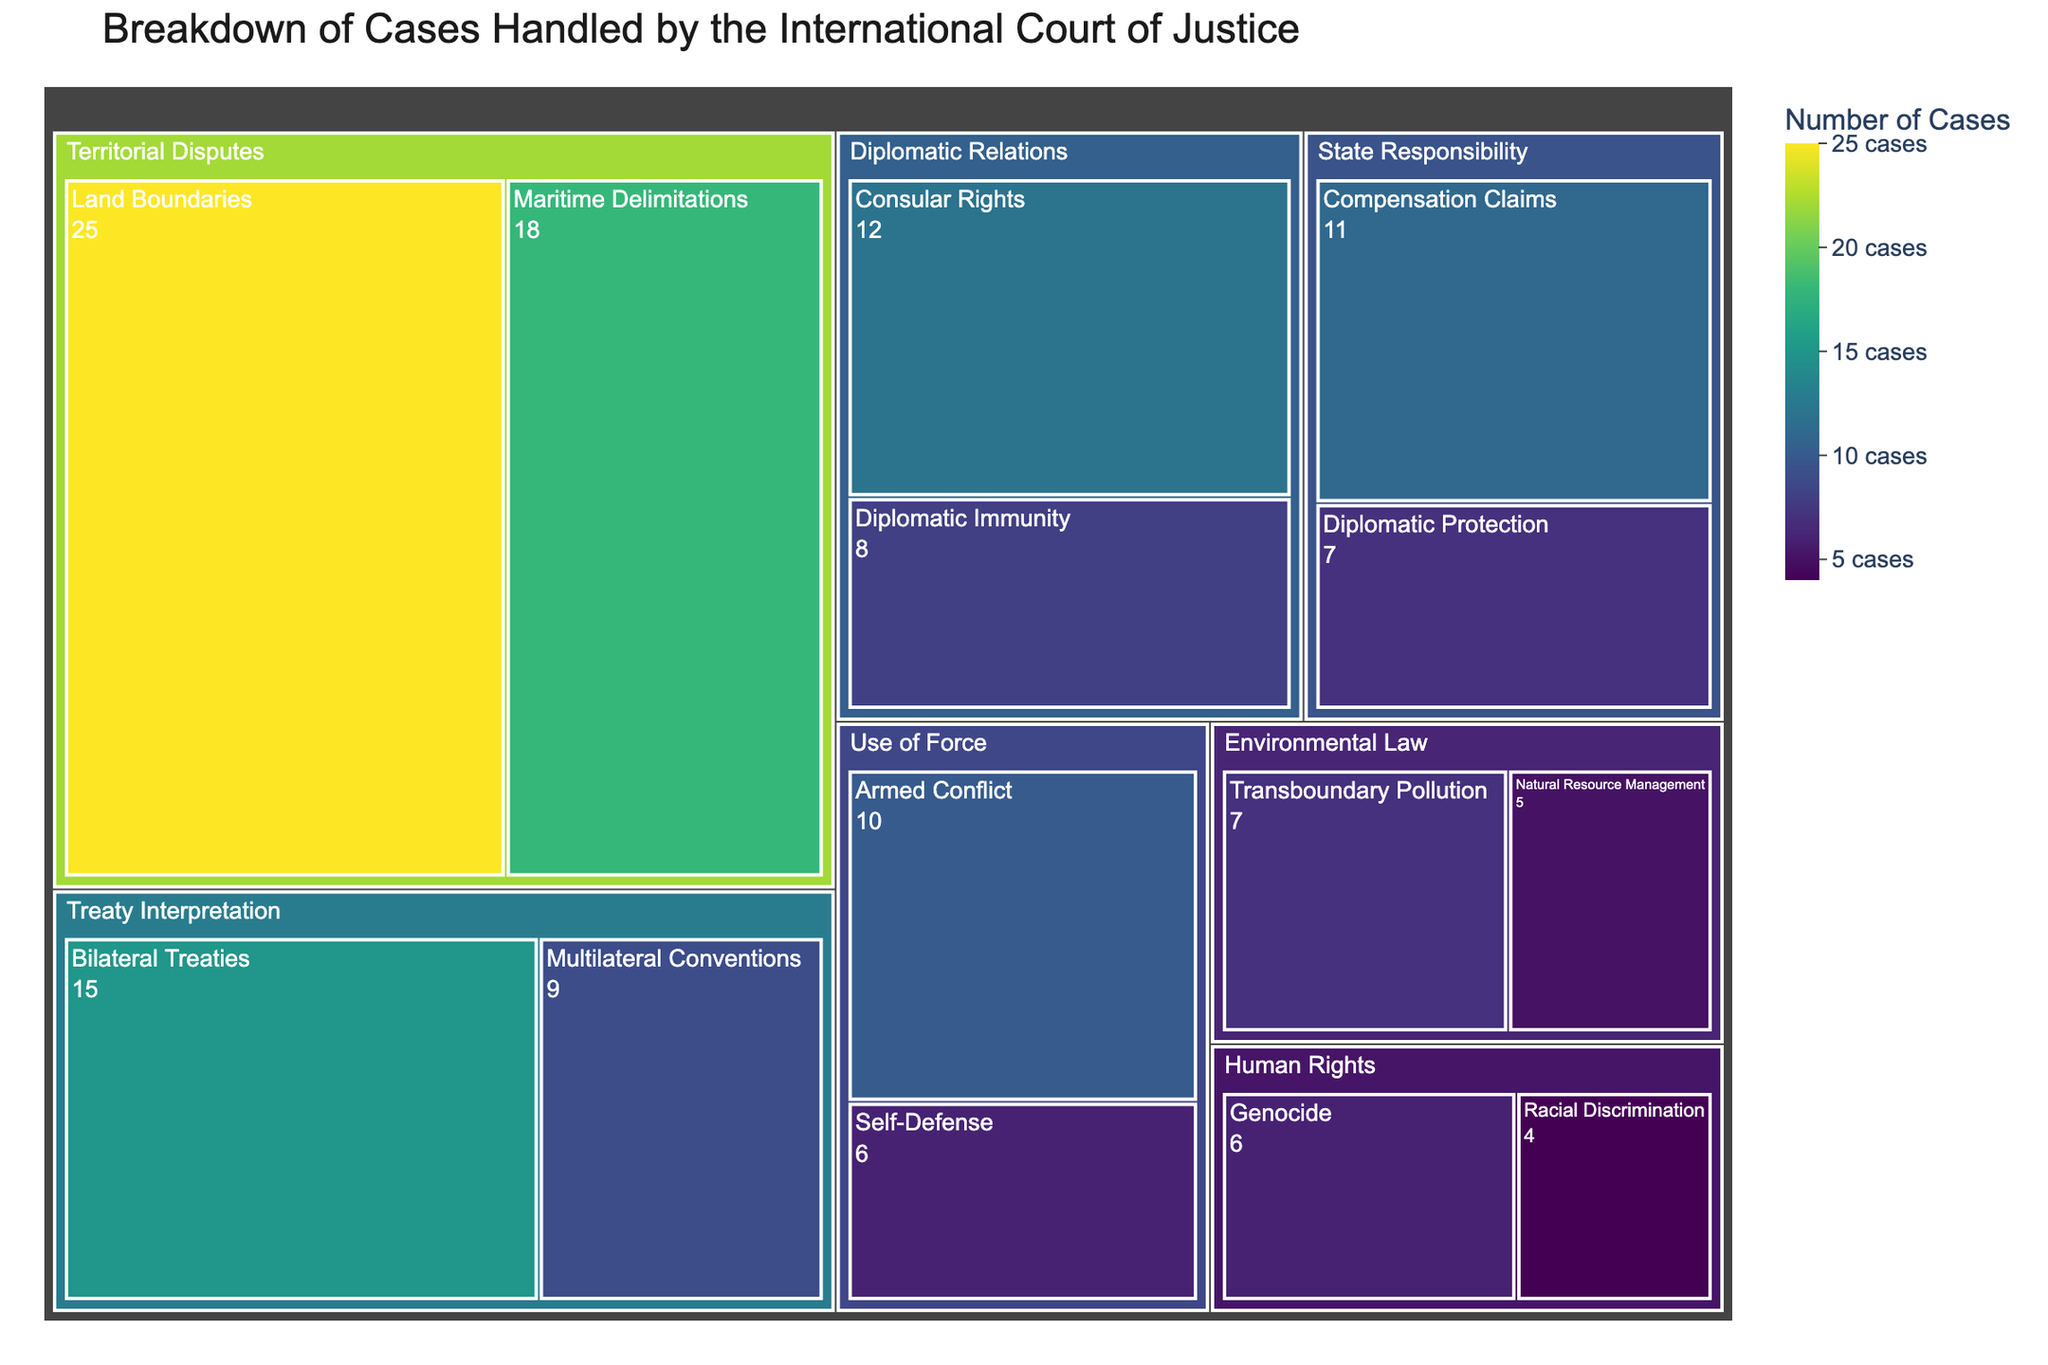what is the total number of cases handled by the International Court of Justice across all categories? To find the total number of cases, add up the values of all subcategories: 25 + 18 + 12 + 8 + 6 + 4 + 7 + 5 + 10 + 6 + 15 + 9 + 11 + 7 = 143
Answer: 143 Which subcategory within Human Rights has more cases? Human Rights is split into two subcategories: Genocide (6 cases) and Racial Discrimination (4 cases). Comparing the two, Genocide has more cases.
Answer: Genocide How many more cases does "Territorial Disputes" have compared to "Environmental Law"? Summing the subcategories of each: Territorial Disputes = 25 + 18 = 43. Environmental Law = 7 + 5 = 12. The difference is 43 - 12 = 31.
Answer: 31 What's the average number of cases in "Use of Force" subcategories? Use of Force has Armed Conflict (10 cases) and Self-Defense (6 cases). To find the average, add them up and divide by the number of subcategories: (10 + 6) / 2 = 8.
Answer: 8 Which category has the least number of cases overall? Summing the subcategories for each category, Environmental Law has the fewest total cases with 7 + 5 = 12 cases.
Answer: Environmental Law Between "Diplomatic Relations" and "State Responsibility," which has a higher total and by how much? Diplomatic Relations total: 12 (Consular Rights) + 8 (Diplomatic Immunity) = 20. State Responsibility total: 11 (Compensation Claims) + 7 (Diplomatic Protection) = 18. Difference: 20 - 18 = 2.
Answer: Diplomatic Relations by 2 Which subcategory has the highest number of cases? The subcategories and their values are visually represented, and Land Boundaries under Territorial Disputes has the highest with 25 cases.
Answer: Land Boundaries How does "Treaty Interpretation" compare to "Territorial Disputes" in terms of total cases? Treaty Interpretation total: 15 (Bilateral Treaties) + 9 (Multilateral Conventions) = 24. Territorial Disputes total: 25 (Land Boundaries) + 18 (Maritime Delimitations) = 43. Hence, Territorial Disputes has more: 43 vs. 24.
Answer: Territorial Disputes with 19 more cases If the top 3 subcategories with the most cases are selected, what's their combined total? The subcategories with the most cases are Land Boundaries (25), Maritime Delimitations (18), and Bilateral Treaties (15). Adding these: 25 + 18 + 15 = 58.
Answer: 58 Which subcategory in "Human Rights" has fewer cases, and what's the percentage difference from the other subcategory in its category? Racial Discrimination has 4 cases, Genocide has 6. Difference is 6 - 4 = 2. Percentage difference: (2 / 6) * 100 ≈ 33.33%
Answer: Racial Discrimination, 33.33% 